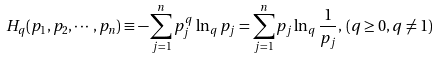Convert formula to latex. <formula><loc_0><loc_0><loc_500><loc_500>H _ { q } ( p _ { 1 } , p _ { 2 } , \cdots , p _ { n } ) \equiv - \sum _ { j = 1 } ^ { n } p _ { j } ^ { q } \ln _ { q } p _ { j } = \sum _ { j = 1 } ^ { n } p _ { j } \ln _ { q } \frac { 1 } { p _ { j } } , \, ( q \geq 0 , q \neq 1 )</formula> 